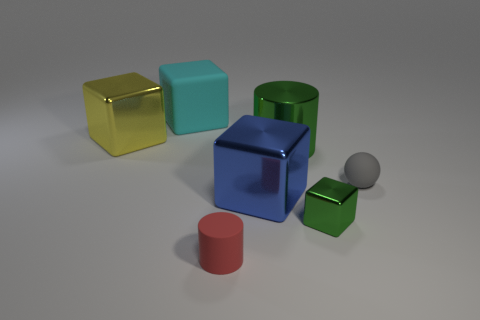Add 1 large blue matte cylinders. How many objects exist? 8 Subtract all cylinders. How many objects are left? 5 Subtract 0 blue cylinders. How many objects are left? 7 Subtract all small green metallic things. Subtract all metal objects. How many objects are left? 2 Add 7 small green things. How many small green things are left? 8 Add 1 large purple cylinders. How many large purple cylinders exist? 1 